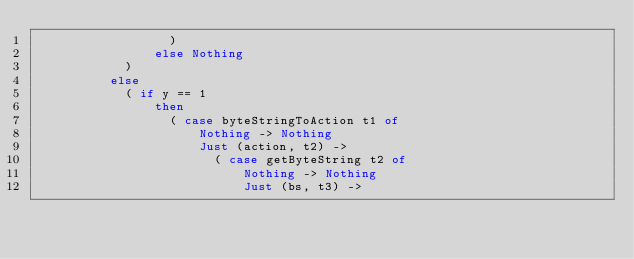Convert code to text. <code><loc_0><loc_0><loc_500><loc_500><_Haskell_>                  )
                else Nothing
            )
          else
            ( if y == 1
                then
                  ( case byteStringToAction t1 of
                      Nothing -> Nothing
                      Just (action, t2) ->
                        ( case getByteString t2 of
                            Nothing -> Nothing
                            Just (bs, t3) -></code> 